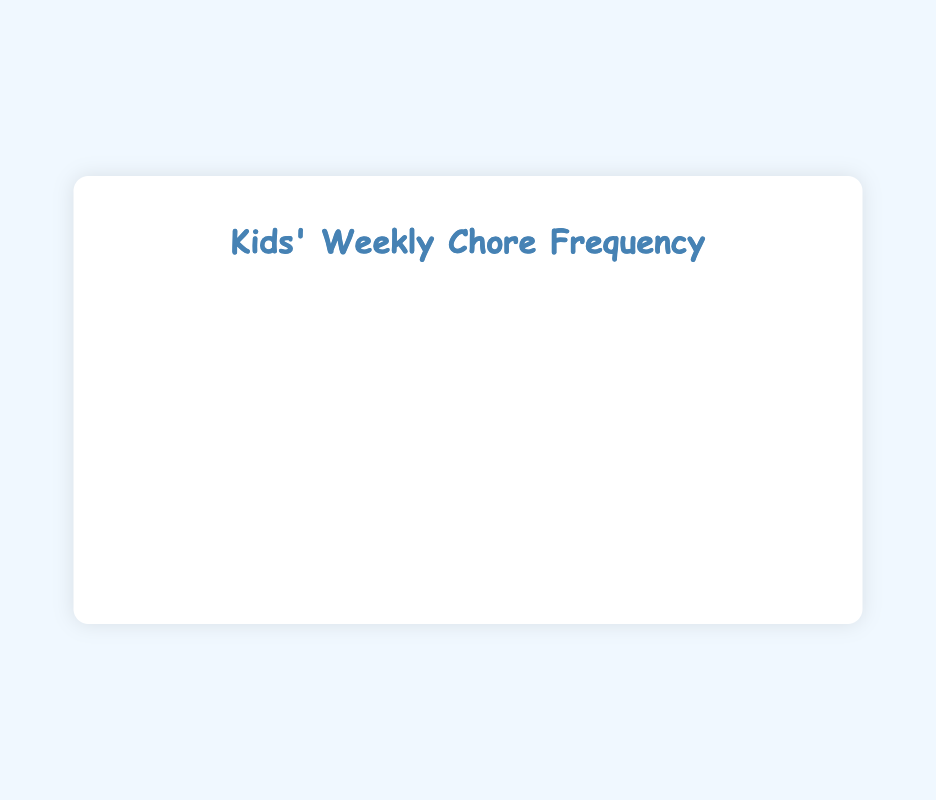Which chore is done the most frequently? The bar for "Feeding pets" is the longest, indicating it is done 7 times per week, which is more than any other chore.
Answer: Feeding pets How often is lawn mowing done per week? The bar for "Mowing the lawn" is the shortest, indicating it is done only 1 time per week.
Answer: 1 time per week Which chore is done more often: vacuuming floors or helping with meal prep? By comparing the lengths of the bars for "Vacuuming floors" and "Helping with meal prep," both are done 3 times per week.
Answer: Both are done 3 times per week What is the total number of times chores related to the table (setting and clearing) are done per week? Setting the table is done 6 times, and clearing the table is done 6 times. Adding these together: 6+6=12.
Answer: 12 times Which chores are done exactly 6 times per week? The bars for "Doing the dishes," "Setting the table," "Clearing the table," and "Walking the dog" all extend to the value 6 on the x-axis.
Answer: Doing the dishes, Setting the table, Clearing the table, Walking the dog How many chores are done more than 3 times per week? By examining the chart, the chores done more than 3 times per week are "Taking out the trash," "Doing the dishes," "Feeding pets," "Cleaning their rooms," "Setting the table," "Clearing the table," and "Walking the dog." Count them: 7 chores.
Answer: 7 chores Which has a higher frequency: sweeping floors or cleaning bathrooms? The bar for "Sweeping floors" extends to 4, whereas the bar for "Cleaning the bathroom" extends to 2. 4 is greater than 2.
Answer: Sweeping floors What is the average weekly frequency of lawn mowing, vacuuming floors, and watering plants? The frequencies are 1 for lawn mowing, 3 for vacuuming floors, and 3 for watering plants. Summing these values gives 1+3+3=7. Dividing by 3 (number of chores) gives 7/3≈2.33.
Answer: Approximately 2.33 times Is cleaning their rooms done more often than vacuuming floors? The bar for "Cleaning their rooms" extends to 5, while the bar for "Vacuuming floors" extends to 3. 5 is greater than 3.
Answer: Yes What is the combined frequency of laundry and cleaning the bathroom? Laundry is done 2 times per week, and cleaning the bathroom is done 2 times per week. Adding these together: 2+2=4.
Answer: 4 times 